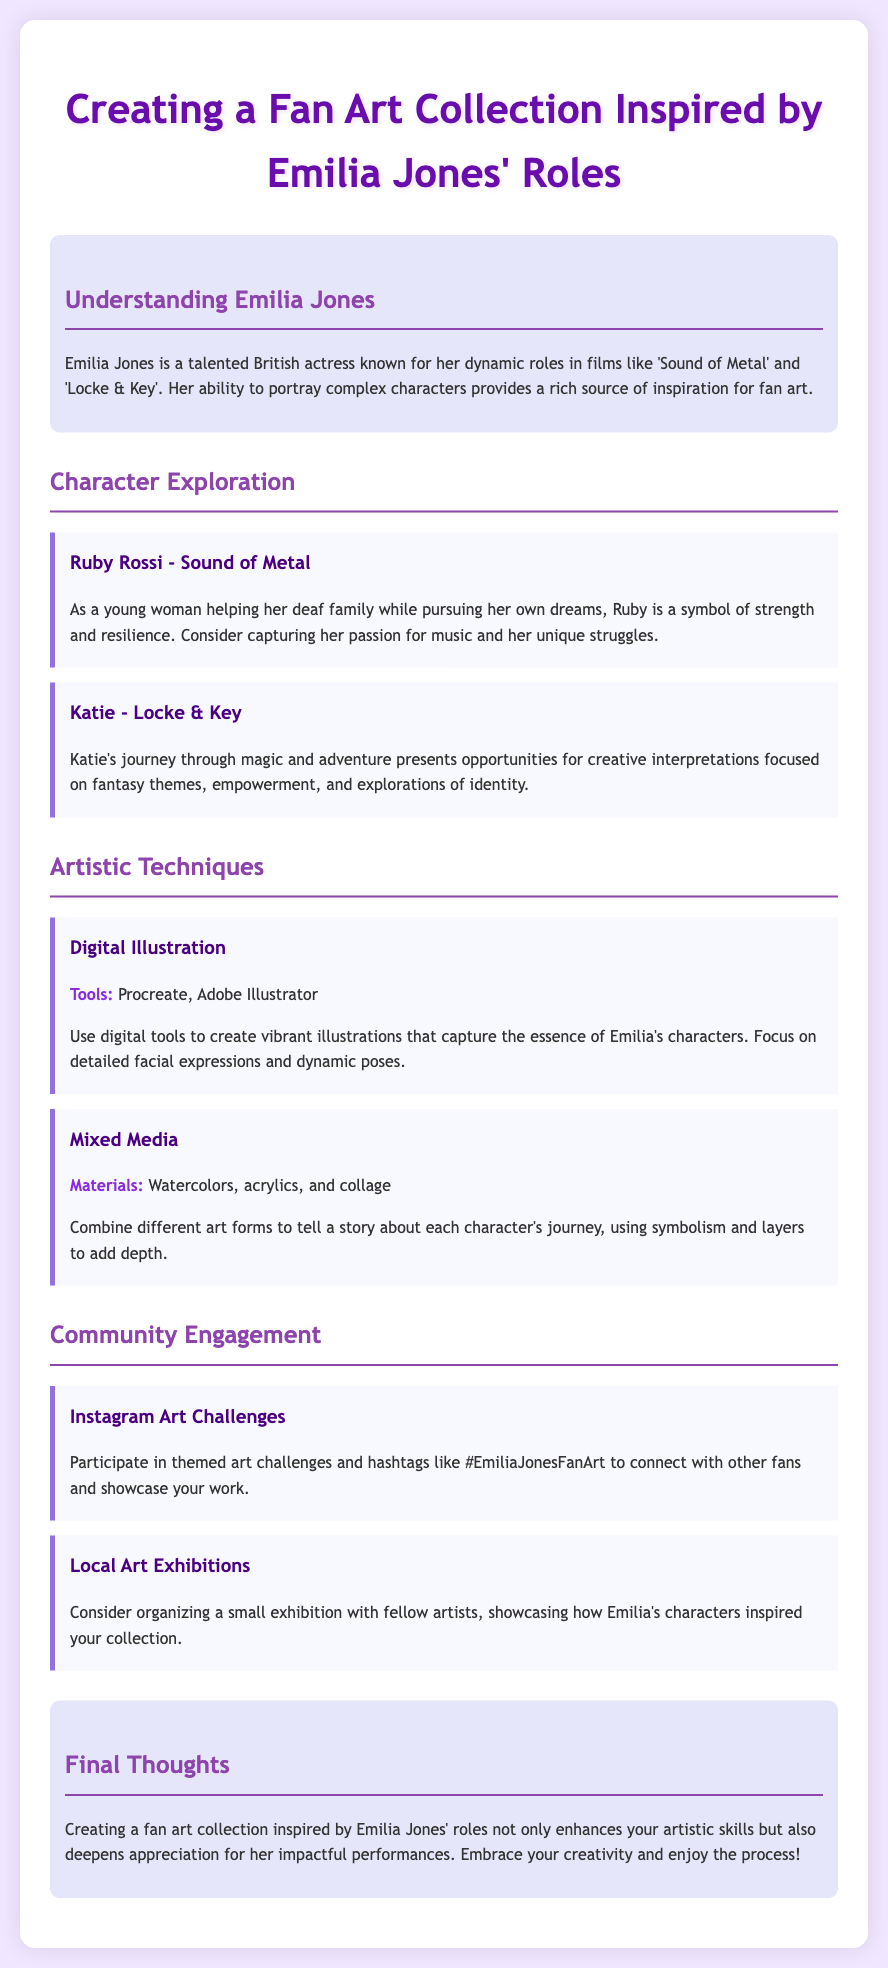what are the names of two characters inspired by Emilia Jones? The document mentions two characters: Ruby Rossi and Katie.
Answer: Ruby Rossi, Katie what film features the character Ruby Rossi? Ruby Rossi is featured in the film 'Sound of Metal'.
Answer: Sound of Metal what character represents themes of magic and adventure? The character Katie from 'Locke & Key' represents themes of magic and adventure.
Answer: Katie what artistic technique uses Procreate and Adobe Illustrator? The document describes "Digital Illustration" as using Procreate and Adobe Illustrator.
Answer: Digital Illustration what is a suggested material for mixed media art? The document lists watercolors, acrylics, and collage as suggested materials for mixed media art.
Answer: Watercolors, acrylics, collage what is the purpose of participating in Instagram art challenges? Participating in Instagram art challenges helps to connect with other fans and showcase artwork.
Answer: Connect with other fans how can local artists showcase their work inspired by Emilia Jones? Local artists can organize a small exhibition to showcase their work inspired by Emilia Jones.
Answer: Organize a small exhibition what is emphasized in the conclusion about creating fan art? The conclusion emphasizes that creating a fan art collection enhances artistic skills and appreciation for Emilia's performances.
Answer: Enhances artistic skills what color is used for the main title text? The main title text is colored #6a0dad.
Answer: #6a0dad 